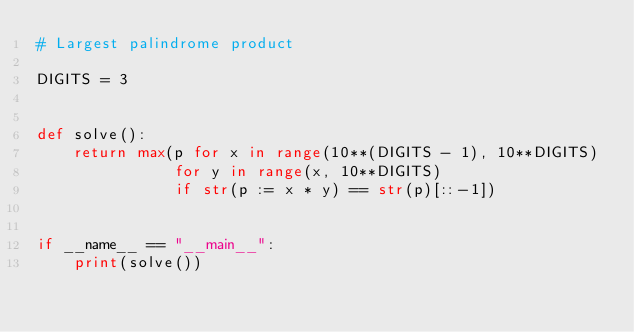<code> <loc_0><loc_0><loc_500><loc_500><_Python_># Largest palindrome product

DIGITS = 3


def solve():
    return max(p for x in range(10**(DIGITS - 1), 10**DIGITS)
               for y in range(x, 10**DIGITS)
               if str(p := x * y) == str(p)[::-1])


if __name__ == "__main__":
    print(solve())
</code> 